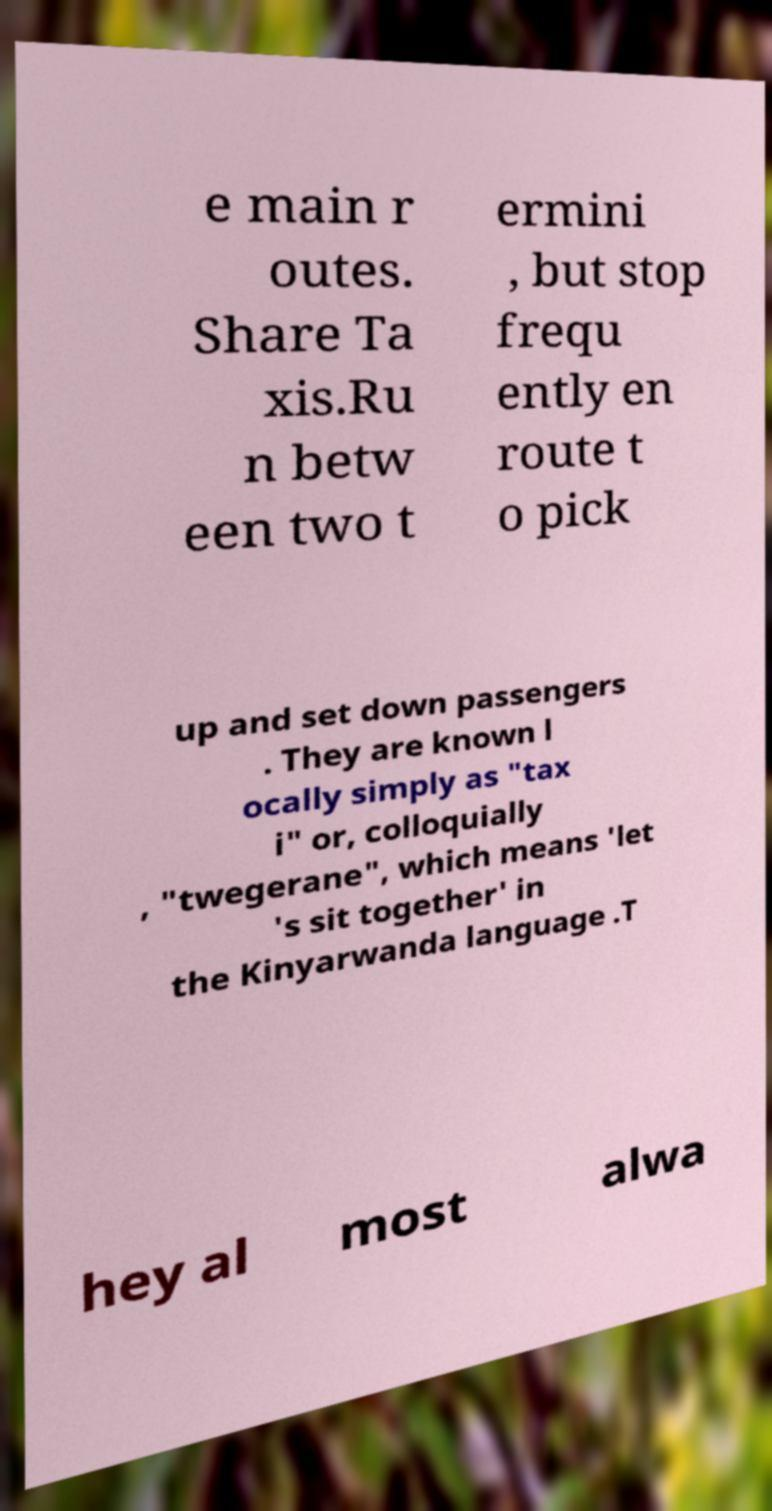Could you extract and type out the text from this image? e main r outes. Share Ta xis.Ru n betw een two t ermini , but stop frequ ently en route t o pick up and set down passengers . They are known l ocally simply as "tax i" or, colloquially , "twegerane", which means 'let 's sit together' in the Kinyarwanda language .T hey al most alwa 